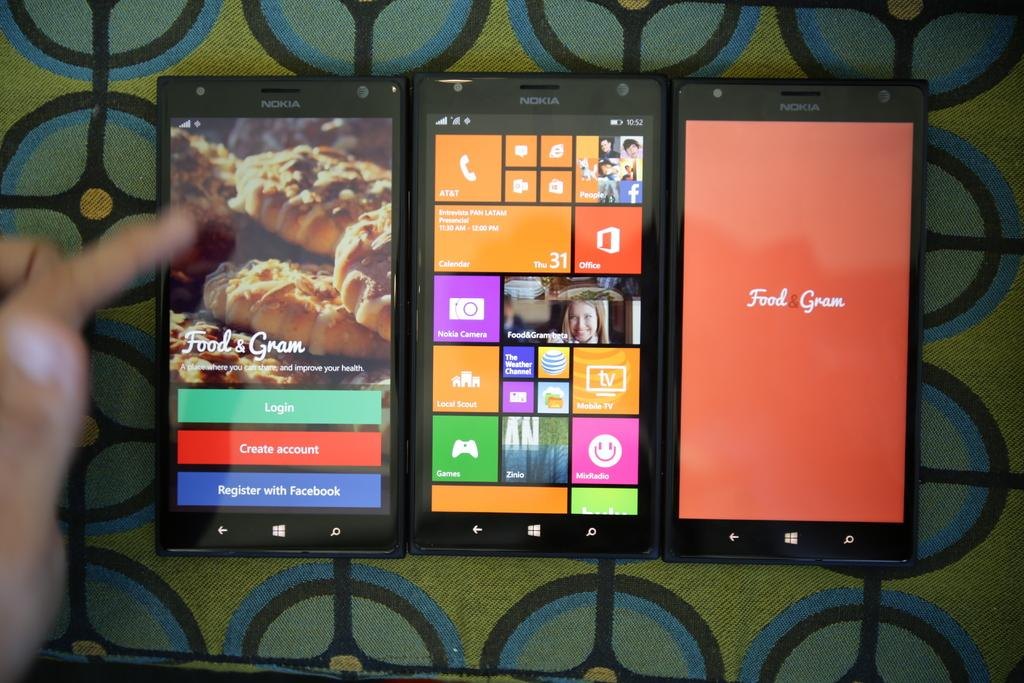<image>
Write a terse but informative summary of the picture. Three Nokia cell phones with all three promoting Food & Gram. 